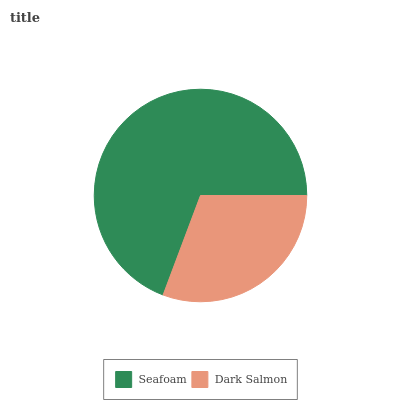Is Dark Salmon the minimum?
Answer yes or no. Yes. Is Seafoam the maximum?
Answer yes or no. Yes. Is Dark Salmon the maximum?
Answer yes or no. No. Is Seafoam greater than Dark Salmon?
Answer yes or no. Yes. Is Dark Salmon less than Seafoam?
Answer yes or no. Yes. Is Dark Salmon greater than Seafoam?
Answer yes or no. No. Is Seafoam less than Dark Salmon?
Answer yes or no. No. Is Seafoam the high median?
Answer yes or no. Yes. Is Dark Salmon the low median?
Answer yes or no. Yes. Is Dark Salmon the high median?
Answer yes or no. No. Is Seafoam the low median?
Answer yes or no. No. 